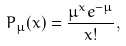<formula> <loc_0><loc_0><loc_500><loc_500>P _ { \mu } ( x ) = \frac { \mu ^ { x } e ^ { - \mu } } { x ! } ,</formula> 